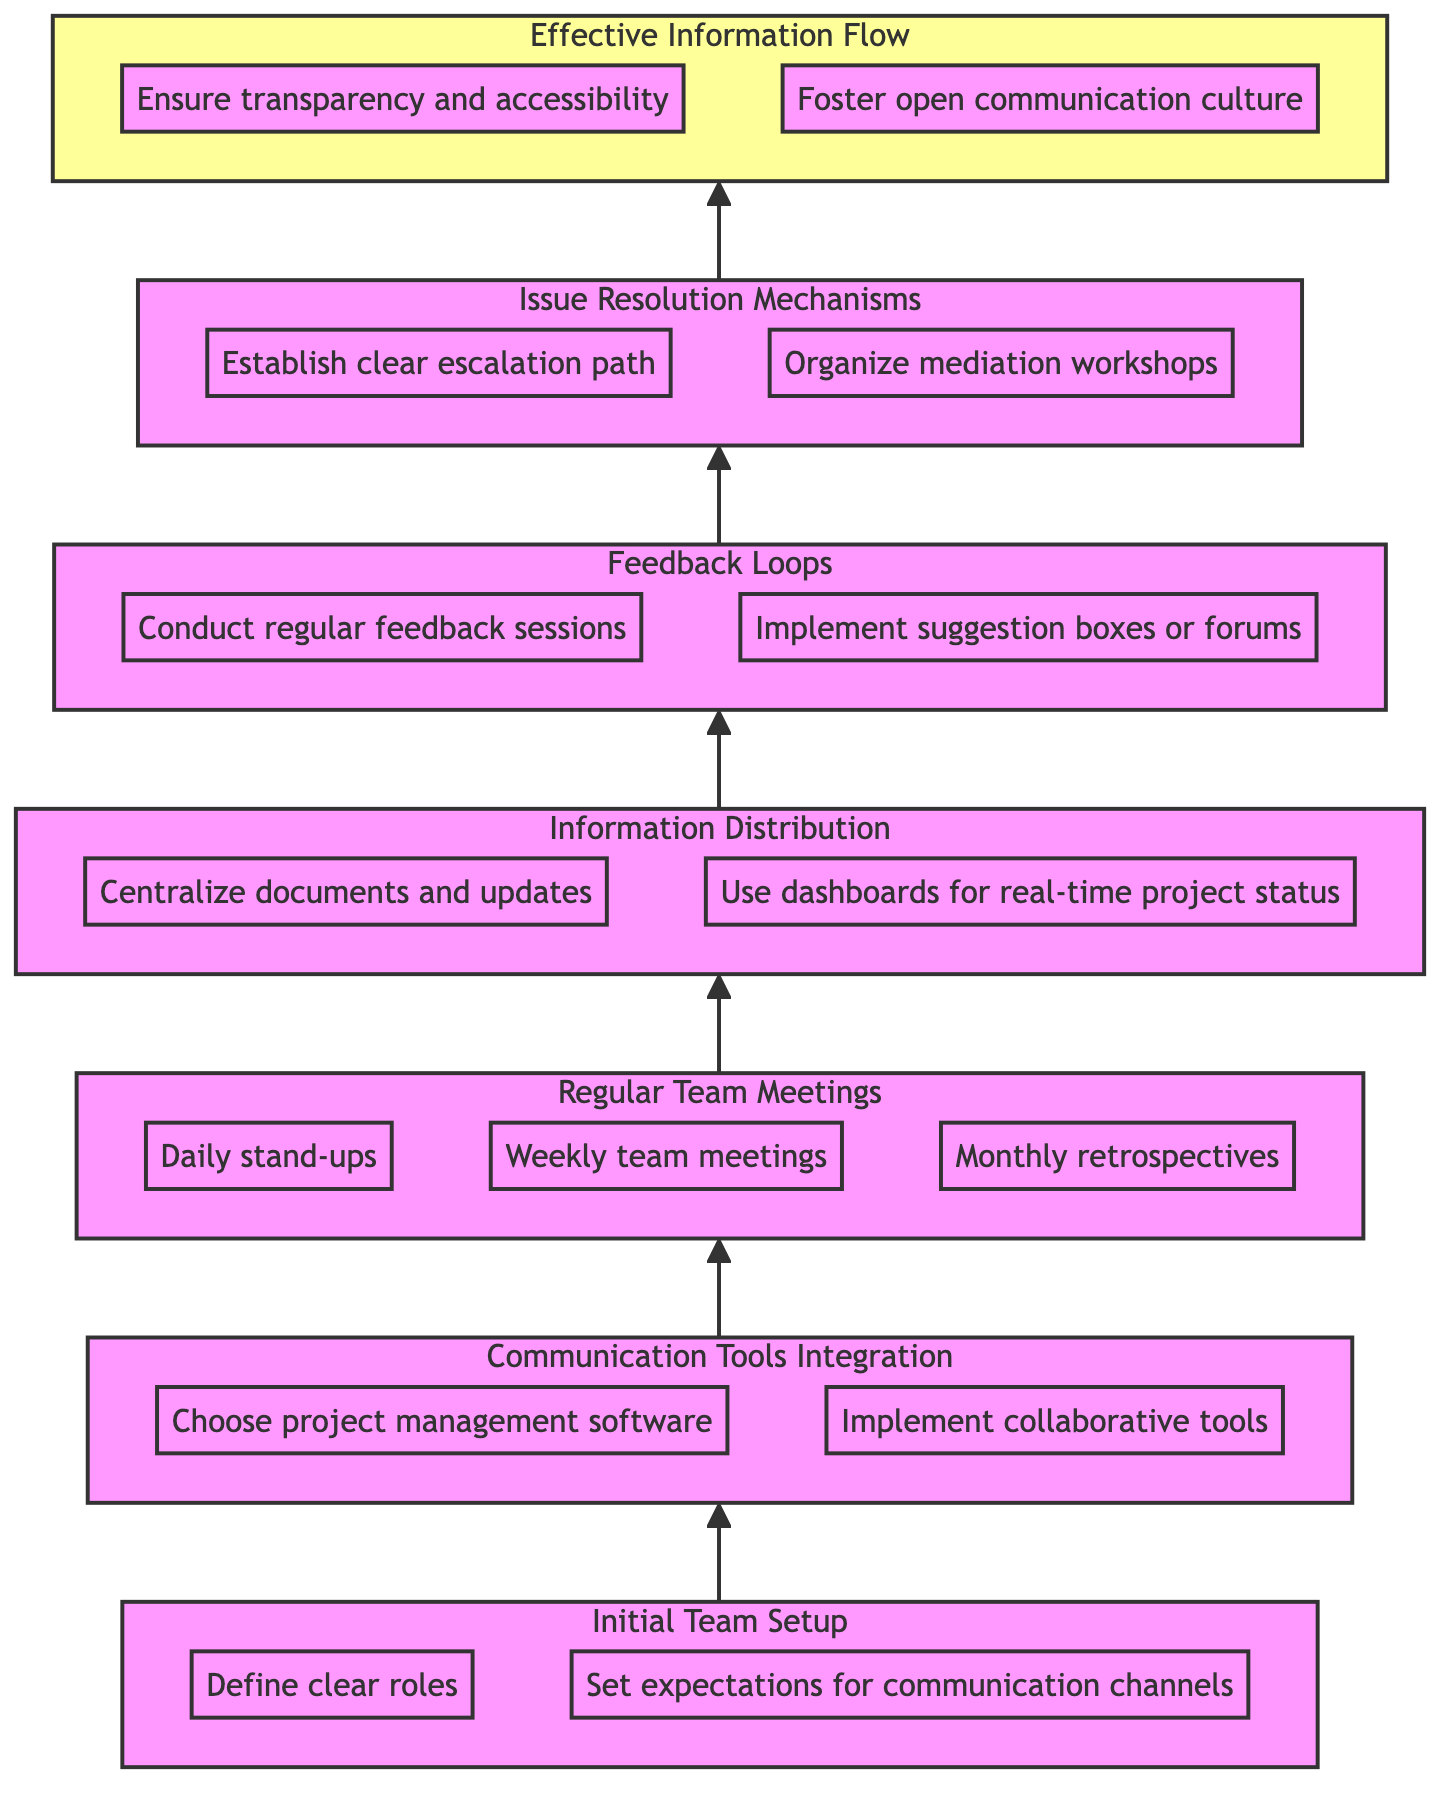What is the first step in the flow chart? The diagram starts with "Initial Team Setup" as the bottommost node that initiates the communication process in a team.
Answer: Initial Team Setup How many main nodes are in the diagram? The diagram consists of six main nodes that represent different stages in enhancing team communication.
Answer: Six What follows after "Regular Team Meetings"? The next step after "Regular Team Meetings" in the flow chart is "Information Distribution," indicating that meetings lead to the sharing of information.
Answer: Information Distribution What are the two components of "Effective Information Flow"? The node "Effective Information Flow" has two sub-components: "Ensure transparency and accessibility of information" and "Foster an open communication culture." These represent the desired outcomes of enhanced communication efforts.
Answer: Ensure transparency and accessibility, Foster open communication culture What do "Feedback Loops" contribute to the communication process? "Feedback Loops" are crucial for creating avenues for continuous improvement, ensuring that team communication evolves based on regular feedback and suggestions from team members.
Answer: Continuous improvement Which node is immediately connected to "Issue Resolution Mechanisms"? "Effective Information Flow" is the node that immediately follows "Issue Resolution Mechanisms," suggesting that proper resolution of issues leads to improved communication within the team.
Answer: Effective Information Flow What tool category is suggested under "Communication Tools Integration"? The integration of communication tools under this node includes selecting project management software and implementing collaborative tools, which are essential for seamless team communication.
Answer: Project management software, Collaborative tools How does "Initial Team Setup" relate to "Communication Tools Integration"? "Initial Team Setup" lays the groundwork for the team, including defining roles and responsibilities, which is essential before integrating communication tools to ensure that all team members are on the same page.
Answer: Lays groundwork What significance does a "clear escalation path" have within "Issue Resolution Mechanisms"? A clear escalation path is vital for effectively managing and resolving conflicts, allowing teams to address issues in a structured manner and preventing communication breakdowns.
Answer: Effective conflict management 